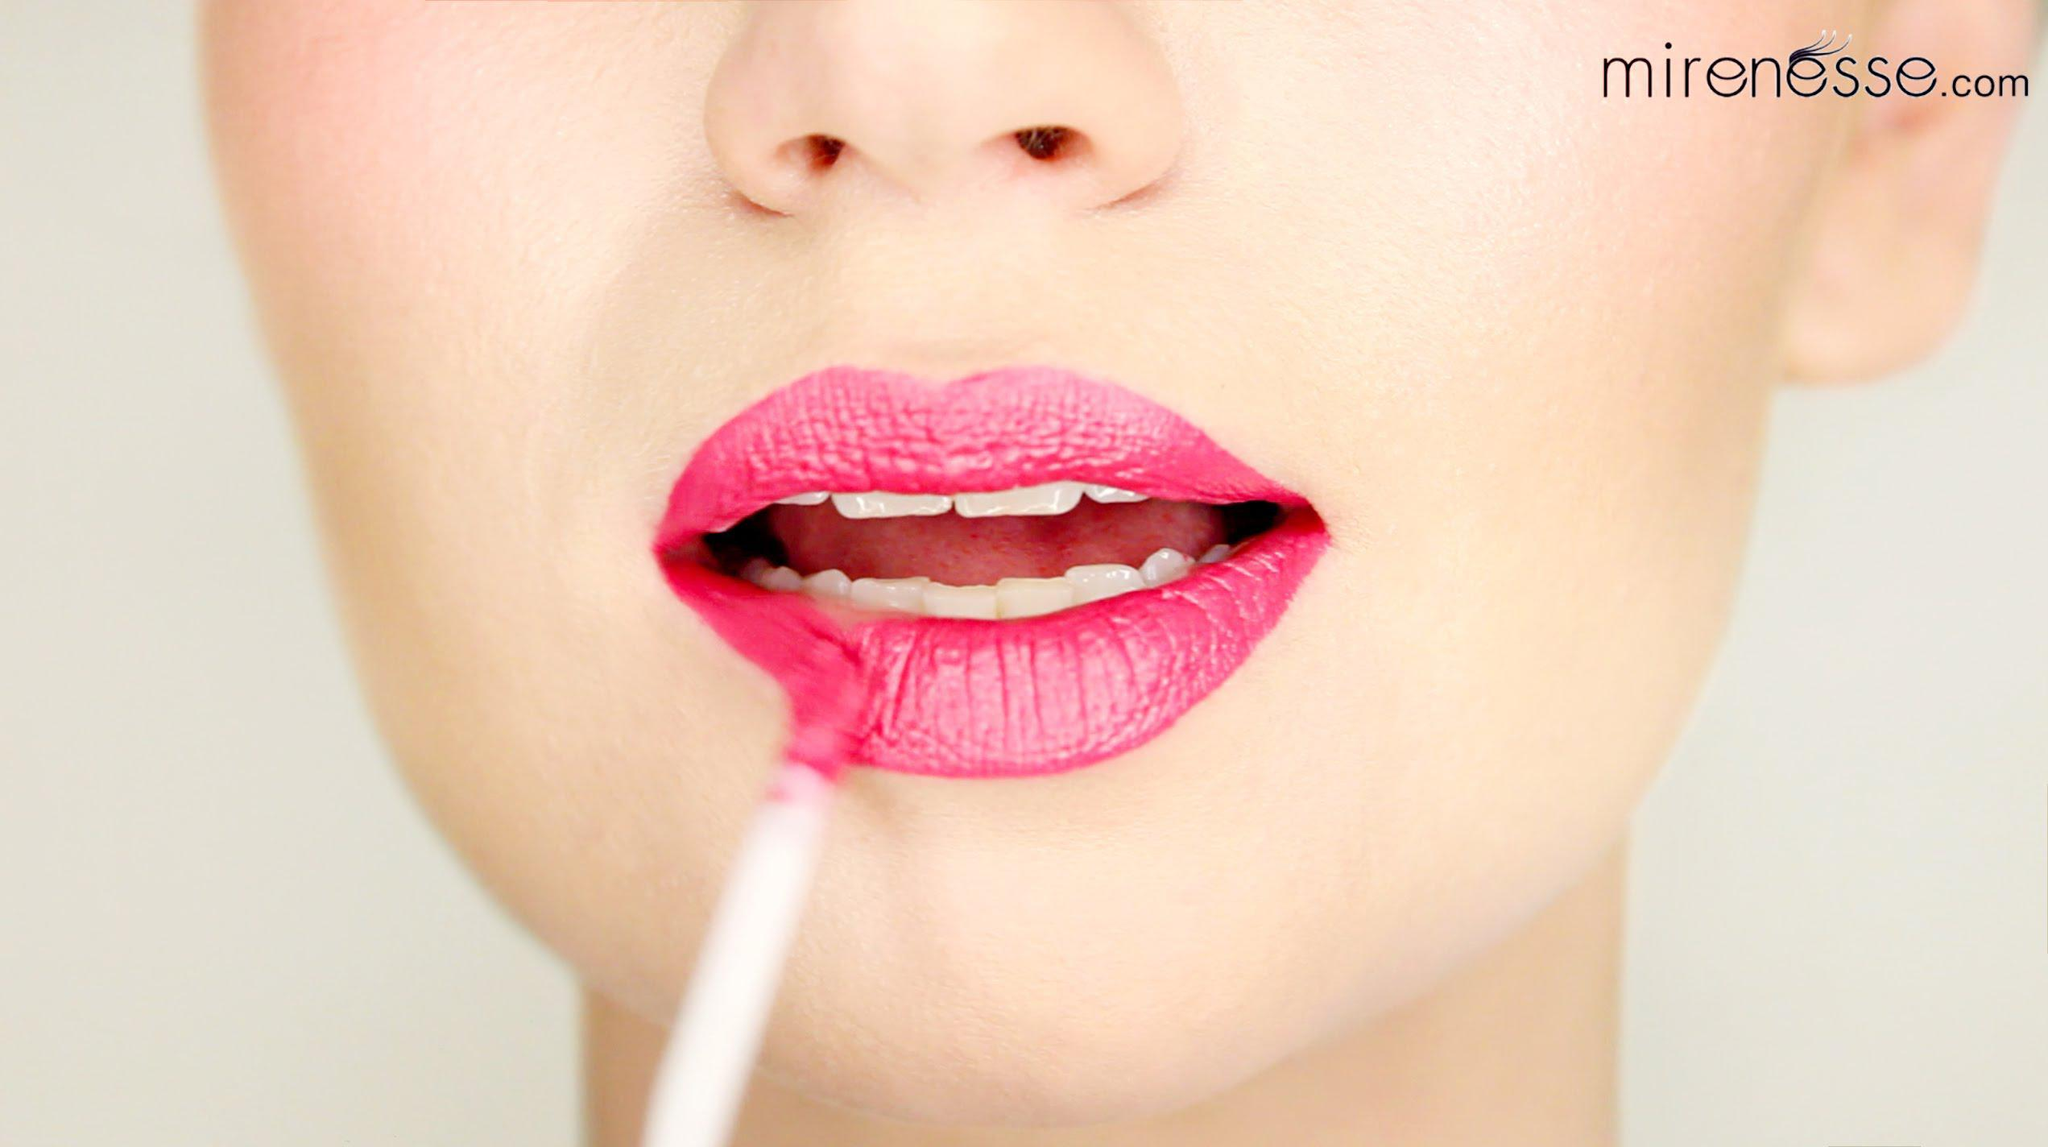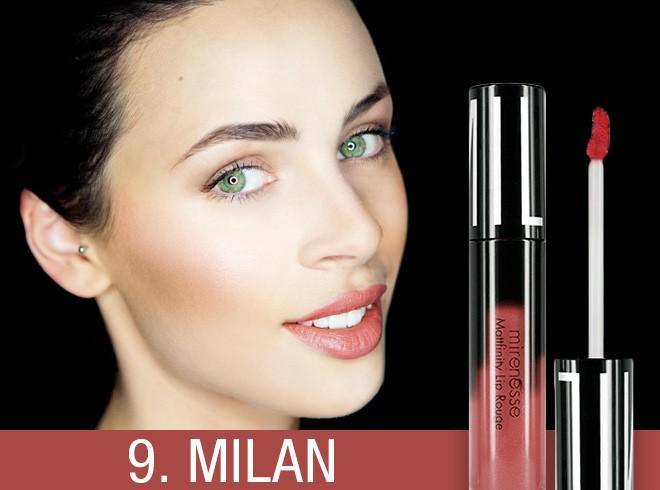The first image is the image on the left, the second image is the image on the right. Assess this claim about the two images: "A woman's teeth are visible in at least one of the images.". Correct or not? Answer yes or no. Yes. The first image is the image on the left, the second image is the image on the right. Assess this claim about the two images: "The woman's eyes can be seen in one of the images". Correct or not? Answer yes or no. Yes. 